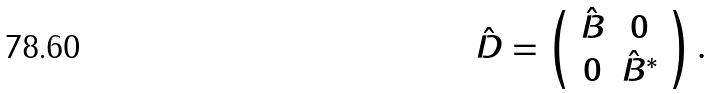Convert formula to latex. <formula><loc_0><loc_0><loc_500><loc_500>\hat { D } = \left ( \begin{array} { c c c } \hat { B } & 0 \\ 0 & \hat { B } ^ { * } \\ \end{array} \right ) .</formula> 